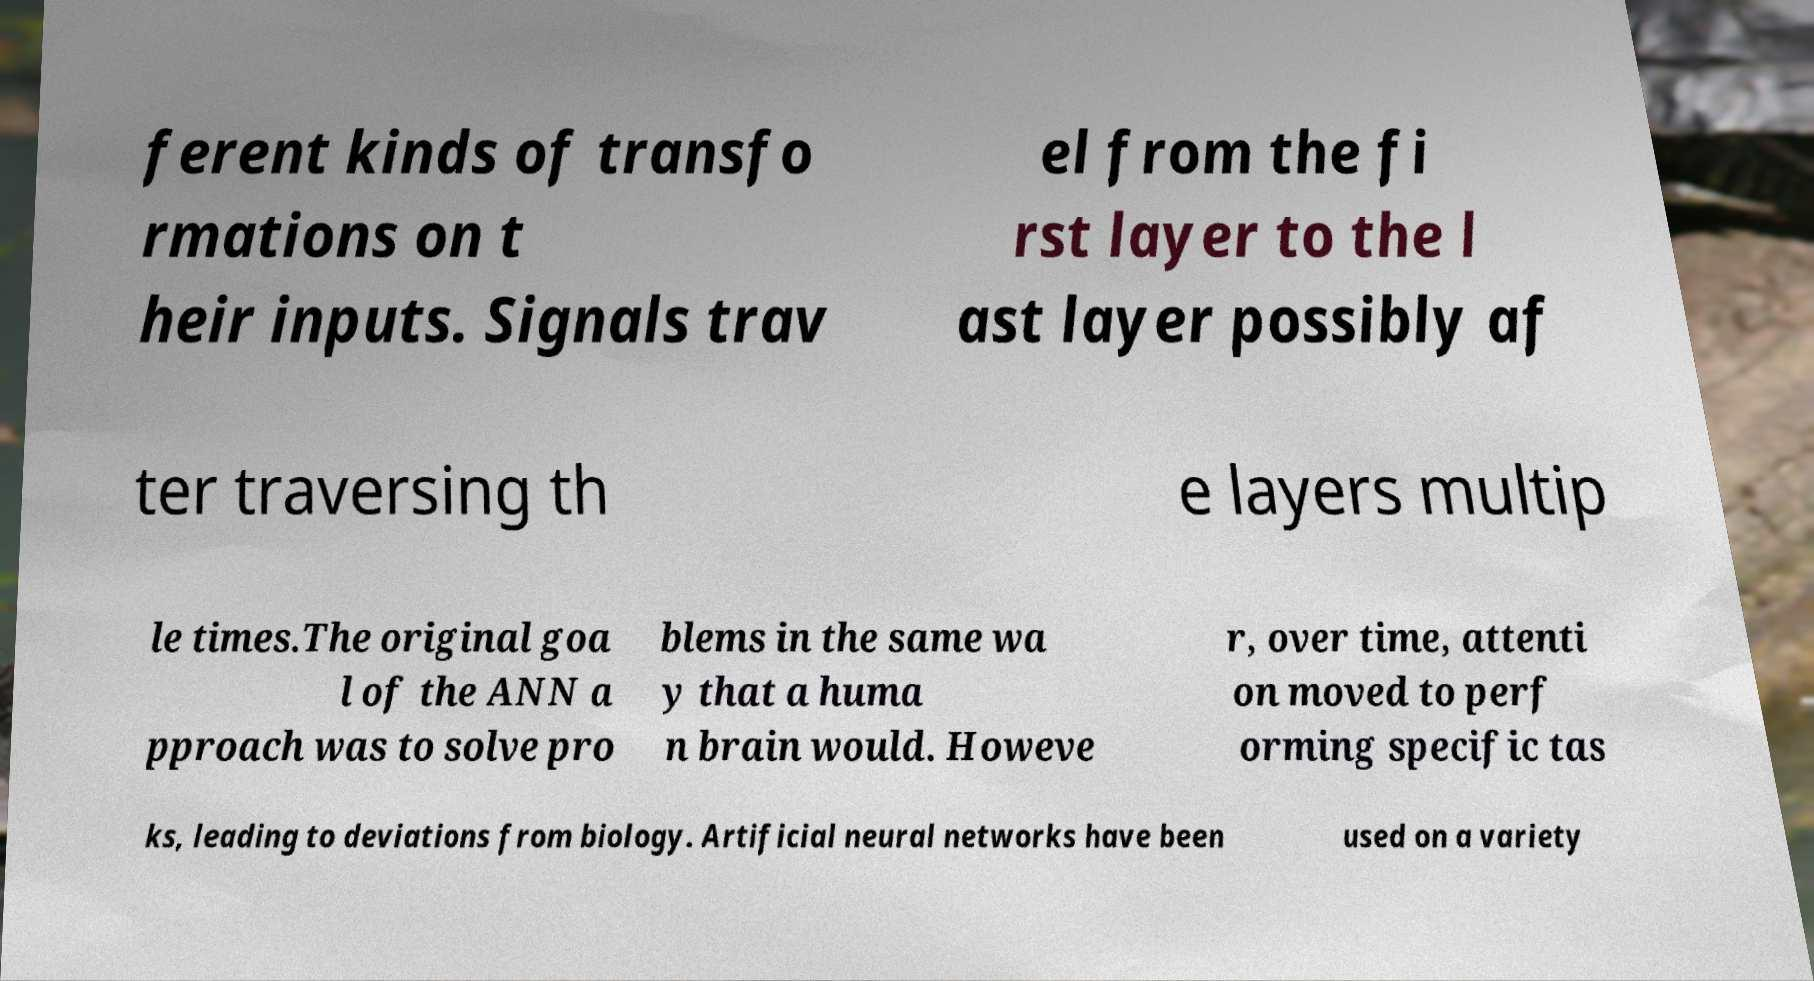Could you assist in decoding the text presented in this image and type it out clearly? ferent kinds of transfo rmations on t heir inputs. Signals trav el from the fi rst layer to the l ast layer possibly af ter traversing th e layers multip le times.The original goa l of the ANN a pproach was to solve pro blems in the same wa y that a huma n brain would. Howeve r, over time, attenti on moved to perf orming specific tas ks, leading to deviations from biology. Artificial neural networks have been used on a variety 